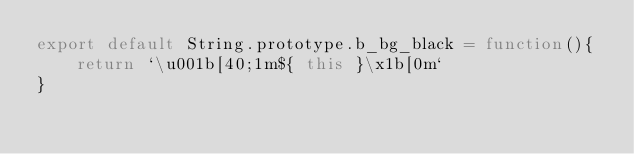Convert code to text. <code><loc_0><loc_0><loc_500><loc_500><_JavaScript_>export default String.prototype.b_bg_black = function(){
    return `\u001b[40;1m${ this }\x1b[0m`
}
</code> 